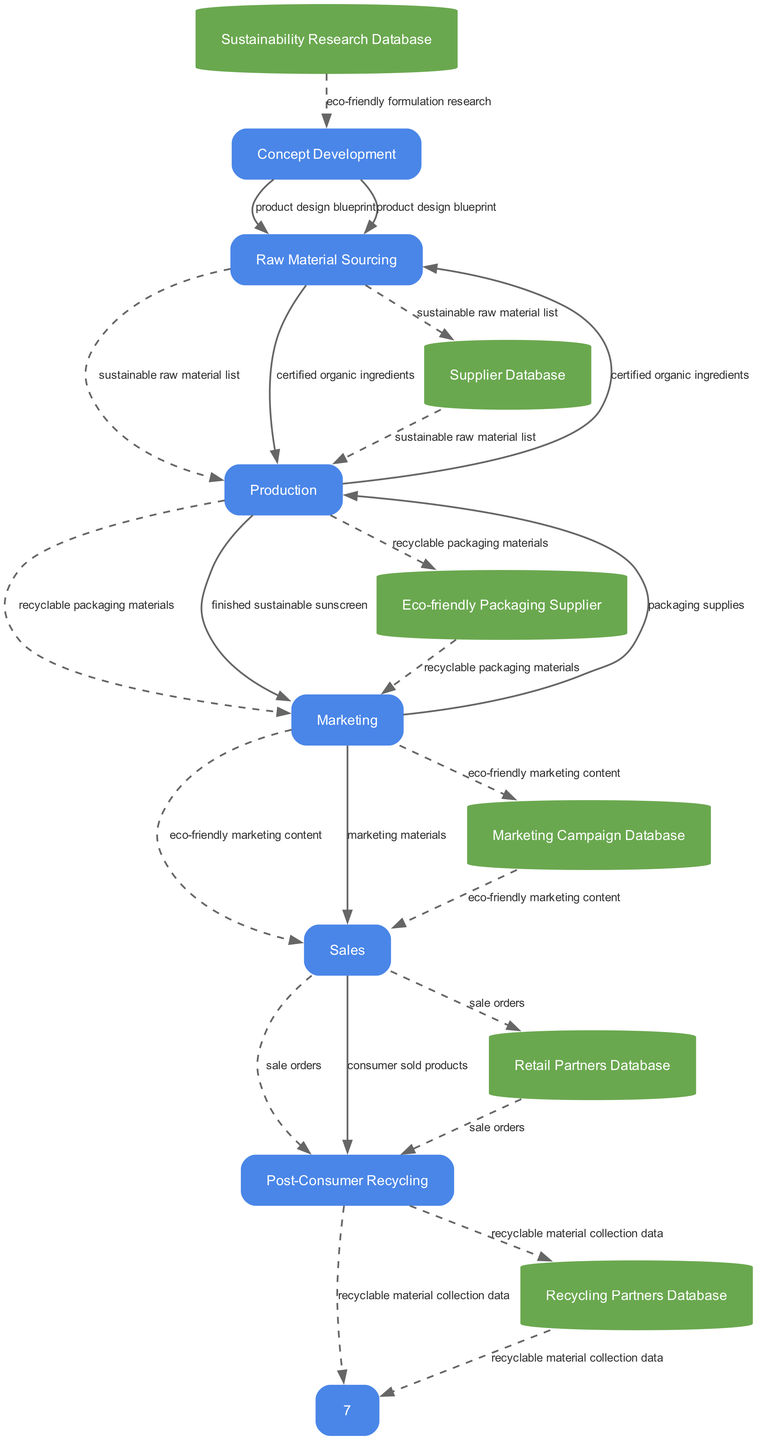What is the first process in the diagram? The first process in the diagram is Concept Development, as it is the initial step listed in the data flow.
Answer: Concept Development How many processes are there in the diagram? The diagram contains six processes: Concept Development, Raw Material Sourcing, Production, Marketing, Sales, and Post-Consumer Recycling.
Answer: Six Which entity provides the sustainable raw material list? The sustainable raw material list is provided by the Supplier Database, which is referenced in the Raw Material Sourcing process.
Answer: Supplier Database What type of data flows from Raw Material Sourcing to Production? The type of data flowing from Raw Material Sourcing to Production is certified organic ingredients.
Answer: Certified organic ingredients What data store is associated with marketing content? The Marketing Campaign Database is the data store associated with eco-friendly marketing content.
Answer: Marketing Campaign Database Which process is directly after Sales? The process directly after Sales is Post-Consumer Recycling, indicating the sequence and flow of data following sales.
Answer: Post-Consumer Recycling How many data flows originate from Production? There are three data flows originating from Production, leading to Marketing and Eco-friendly Packaging Supplier, and involving packaging supplies.
Answer: Three Which process utilizes the consumer sold products? The Post-Consumer Recycling process utilizes consumer sold products, as it is involved in the recycling stage after sales.
Answer: Post-Consumer Recycling What is the data type that flows from Marketing to Sales? The data type flowing from Marketing to Sales is marketing materials, as indicated in the data flows between these processes.
Answer: Marketing materials 